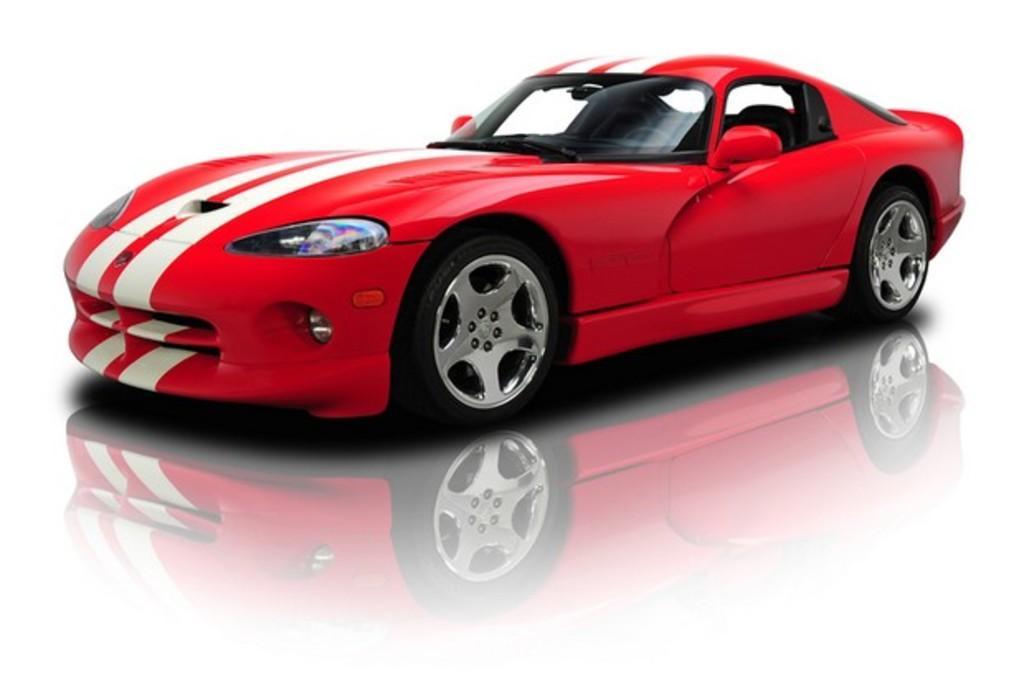How would you summarize this image in a sentence or two? In this image I can see a car which is red, white and black in color. I can see the white colored background. 